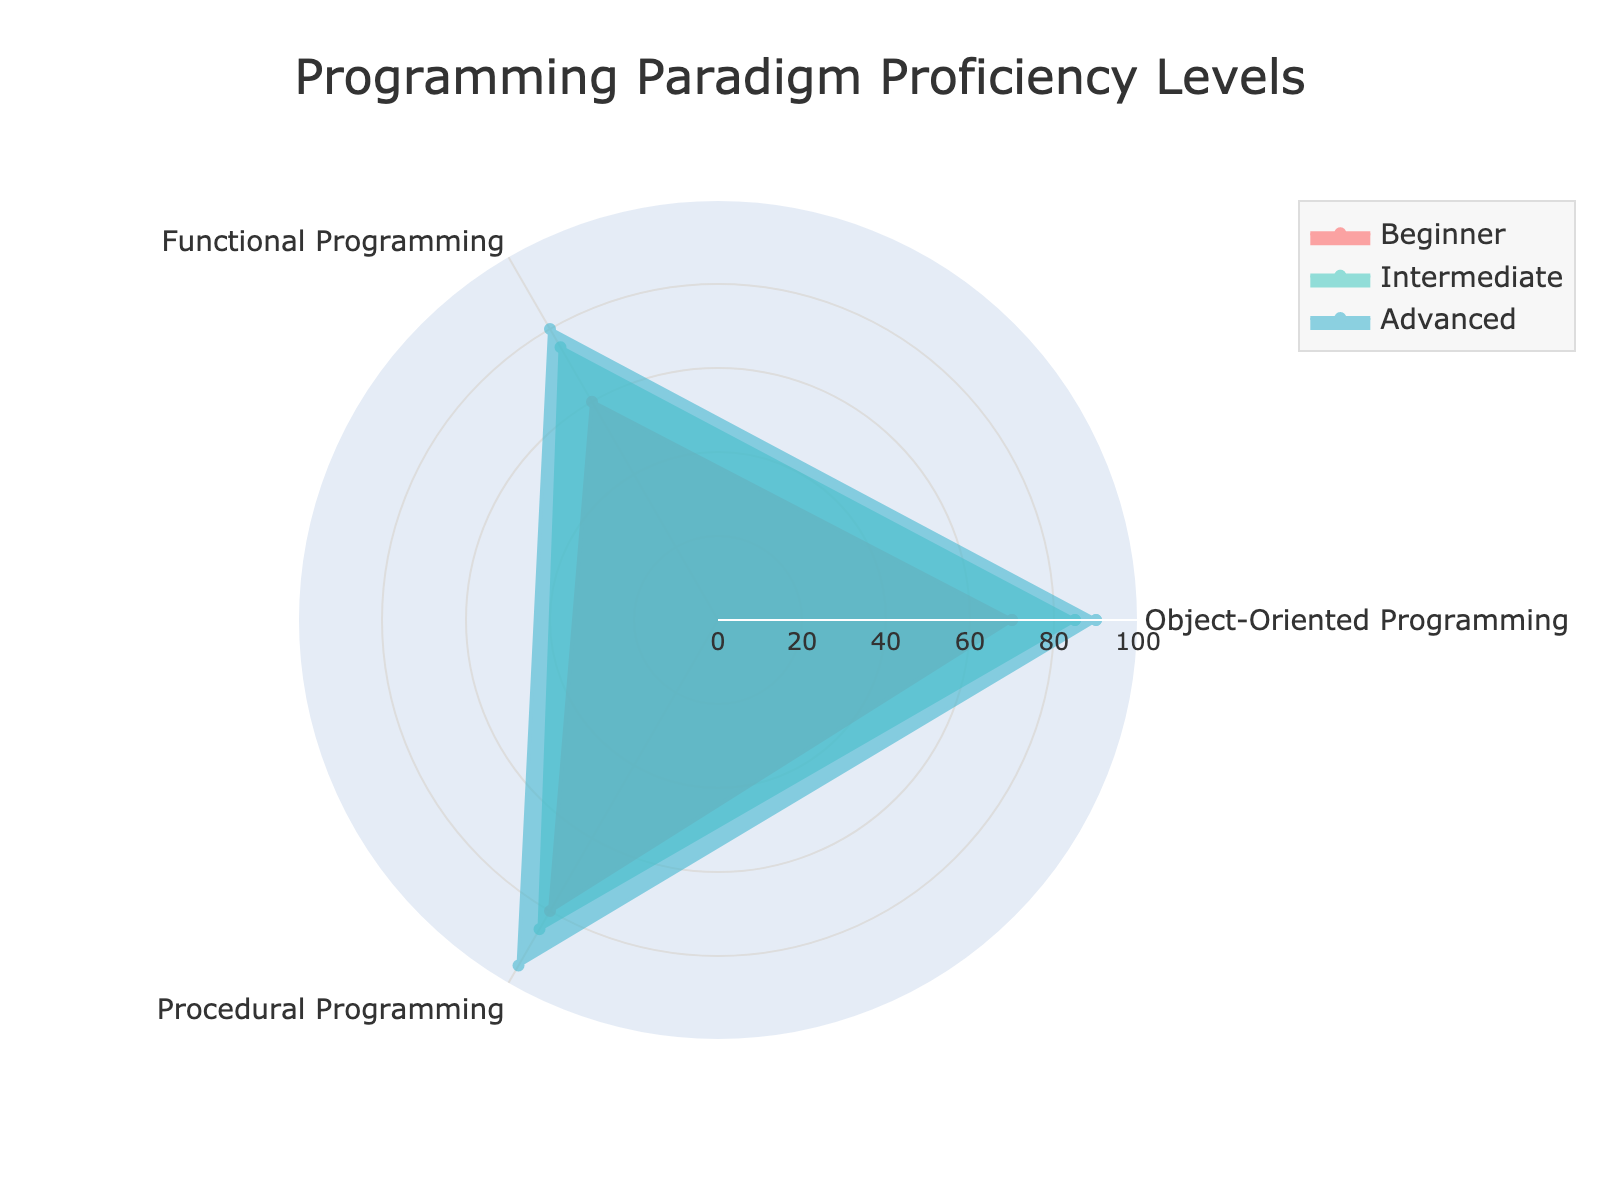What is the proficiency level for advanced skills in Object-Oriented Programming? Look at the radar chart section for Object-Oriented Programming and find the corresponding proficiency level for advanced skills.
Answer: 90 Which programming paradigm has the highest proficiency level at the intermediate skill level? Compare the intermediate skill levels across all programming paradigms: Object-Oriented Programming (85), Functional Programming (75), and Procedural Programming (85). Both Object-Oriented and Procedural Programming have the highest at 85.
Answer: Object-Oriented Programming and Procedural Programming What is the average proficiency level for beginner skills across all programming paradigms? Sum the proficiency levels for beginner skills in all paradigms (Object-Oriented Programming: 70, Functional Programming: 60, Procedural Programming: 80) and divide by the number of paradigms (3). (70 + 60 + 80) / 3
Answer: 70 What is the range of proficiency levels for advanced skills across the paradigms? Find the minimum and maximum proficiency levels for advanced skills: Functional Programming (80), Object-Oriented Programming (90), and Procedural Programming (95). The range is 95 - 80.
Answer: 15 Does any programming paradigm have equal proficiency levels for both beginner and advanced skills? Compare proficiency levels for beginner and advanced skills in each paradigm. Object-Oriented Programming has 70 beginner, 90 advanced; Functional Programming has 60 beginner, 80 advanced; Procedural Programming has 80 beginner, 95 advanced.
Answer: No Which skill level shows the highest consistency in proficiency across all programming paradigms (smallest range)? Calculate the range for each skill level:
- Beginner: 80 - 60 = 20
- Intermediate: 85 - 75 = 10
- Advanced: 95 - 80 = 15
The smallest range is for the intermediate skill level.
Answer: Intermediate What is the sum of proficiency levels for functional programming across all skill levels? Add up the proficiency levels for Functional Programming (Beginner: 60, Intermediate: 75, Advanced: 80). 60 + 75 + 80
Answer: 215 Which programming paradigm demonstrates the highest overall proficiency level? Calculate the total proficiency levels across all skill levels for each paradigm and compare:
- Object-Oriented: 70 + 85 + 90 = 245
- Functional: 60 + 75 + 80 = 215
- Procedural: 80 + 85 + 95 = 260
Procedural Programming has the highest total proficiency level.
Answer: Procedural Programming 